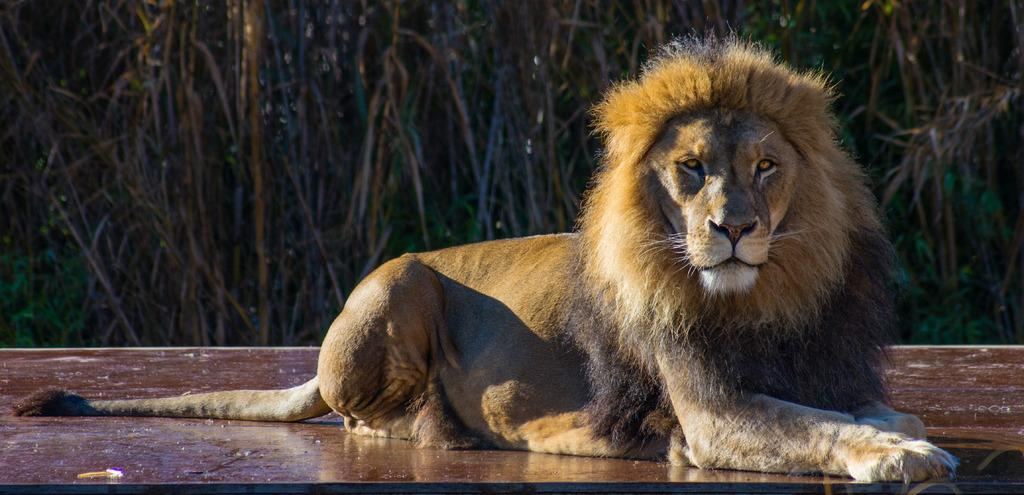What animal is the main subject of the image? There is a lion in the image. What is the lion doing in the image? The lion is sitting on the ground. What can be seen in the background of the image? There are trees in the background of the image. Where is the crowd of people gathered in the image? There is no crowd of people present in the image; it features a lion sitting on the ground with trees in the background. 